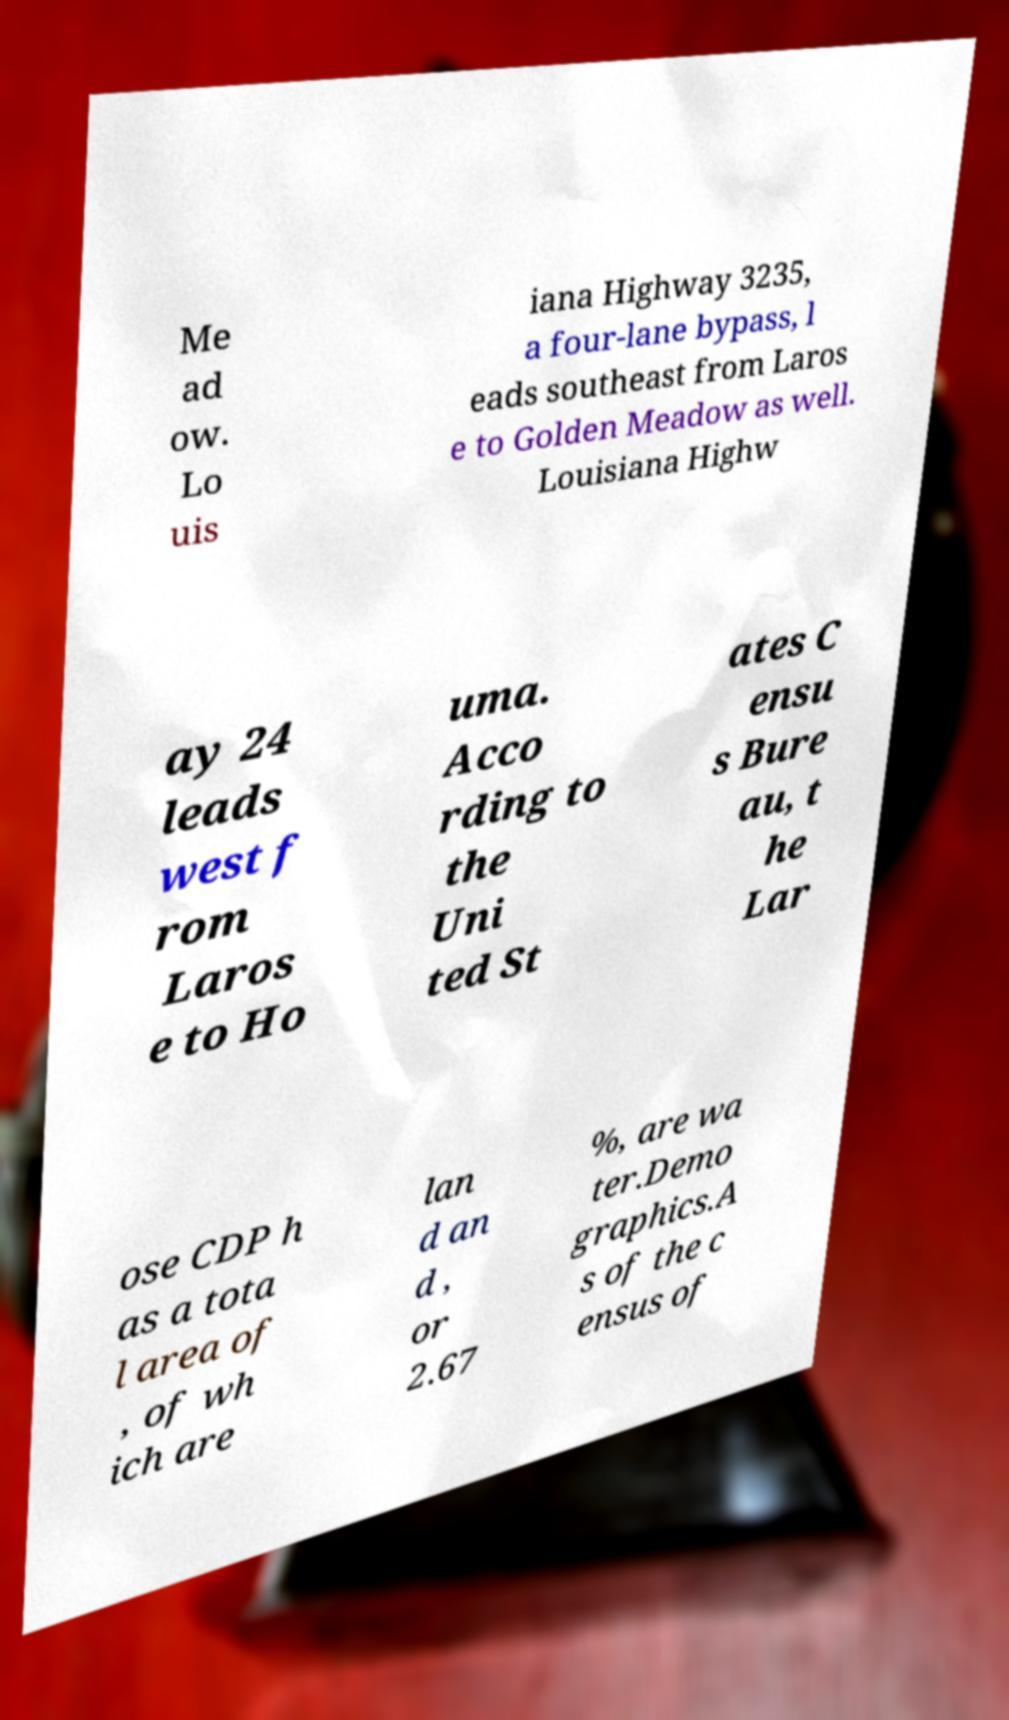Could you extract and type out the text from this image? Me ad ow. Lo uis iana Highway 3235, a four-lane bypass, l eads southeast from Laros e to Golden Meadow as well. Louisiana Highw ay 24 leads west f rom Laros e to Ho uma. Acco rding to the Uni ted St ates C ensu s Bure au, t he Lar ose CDP h as a tota l area of , of wh ich are lan d an d , or 2.67 %, are wa ter.Demo graphics.A s of the c ensus of 